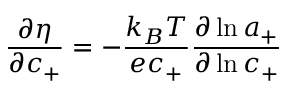Convert formula to latex. <formula><loc_0><loc_0><loc_500><loc_500>\frac { \partial \eta } { \partial c _ { + } } = - \frac { k _ { B } T } { e c _ { + } } \frac { \partial \ln { a _ { + } } } { \partial \ln { c _ { + } } }</formula> 